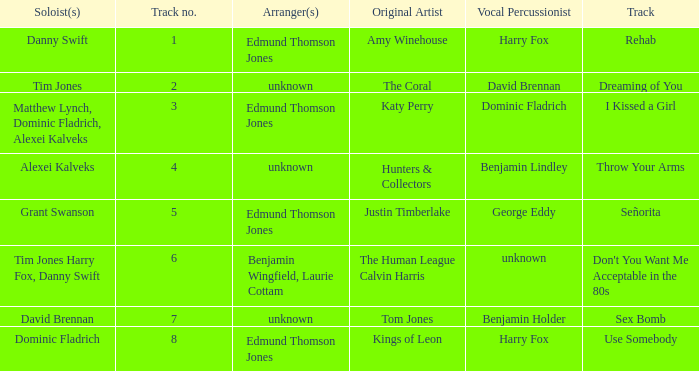Who is the vocal percussionist for Sex Bomb? Benjamin Holder. 